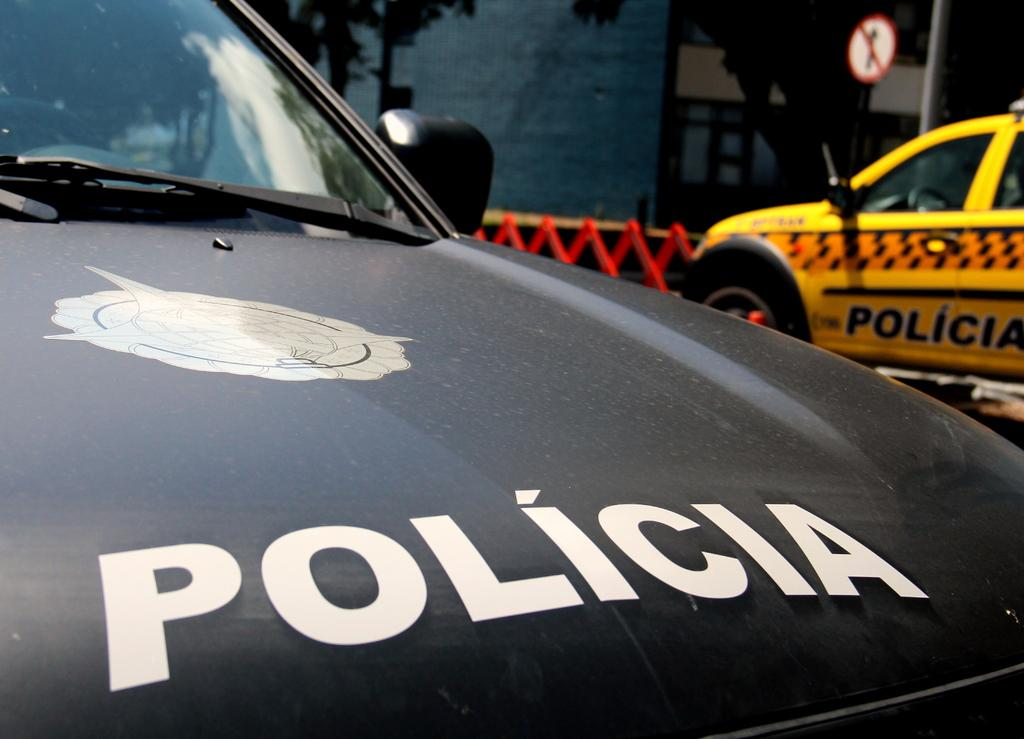<image>
Present a compact description of the photo's key features. the word Policia is on the black car 